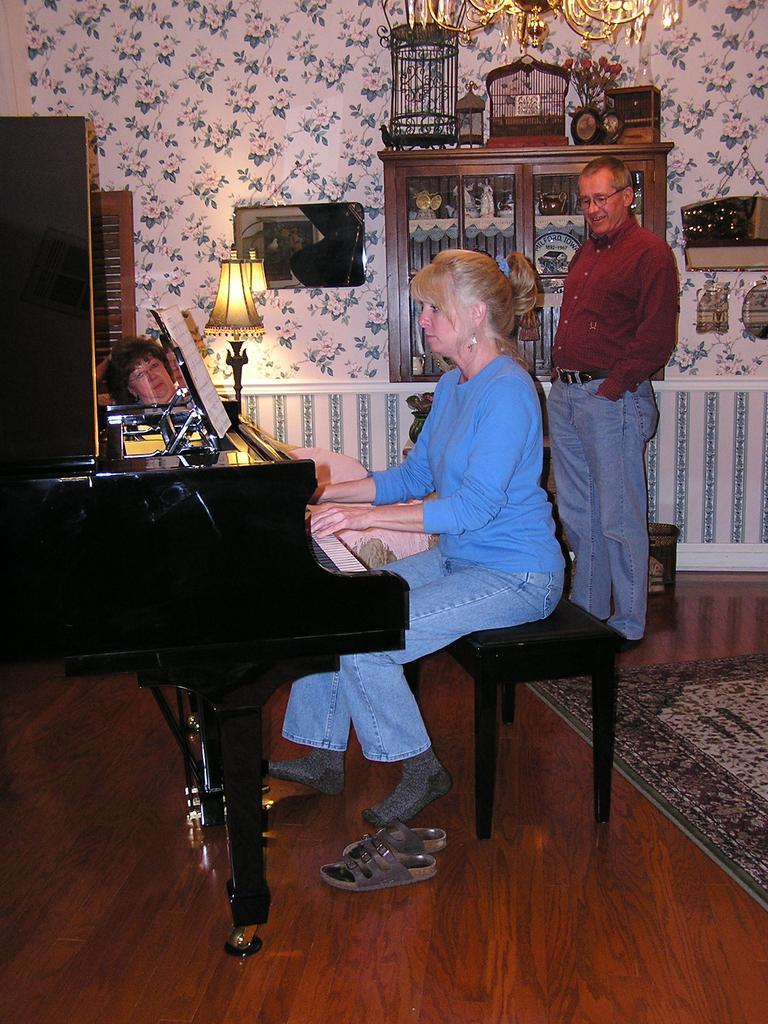Can you describe this image briefly? In this image we can see a woman wearing blue color t-shirt is playing piano. In the background we can see a wall, lamps, cupboards and a person standing. 